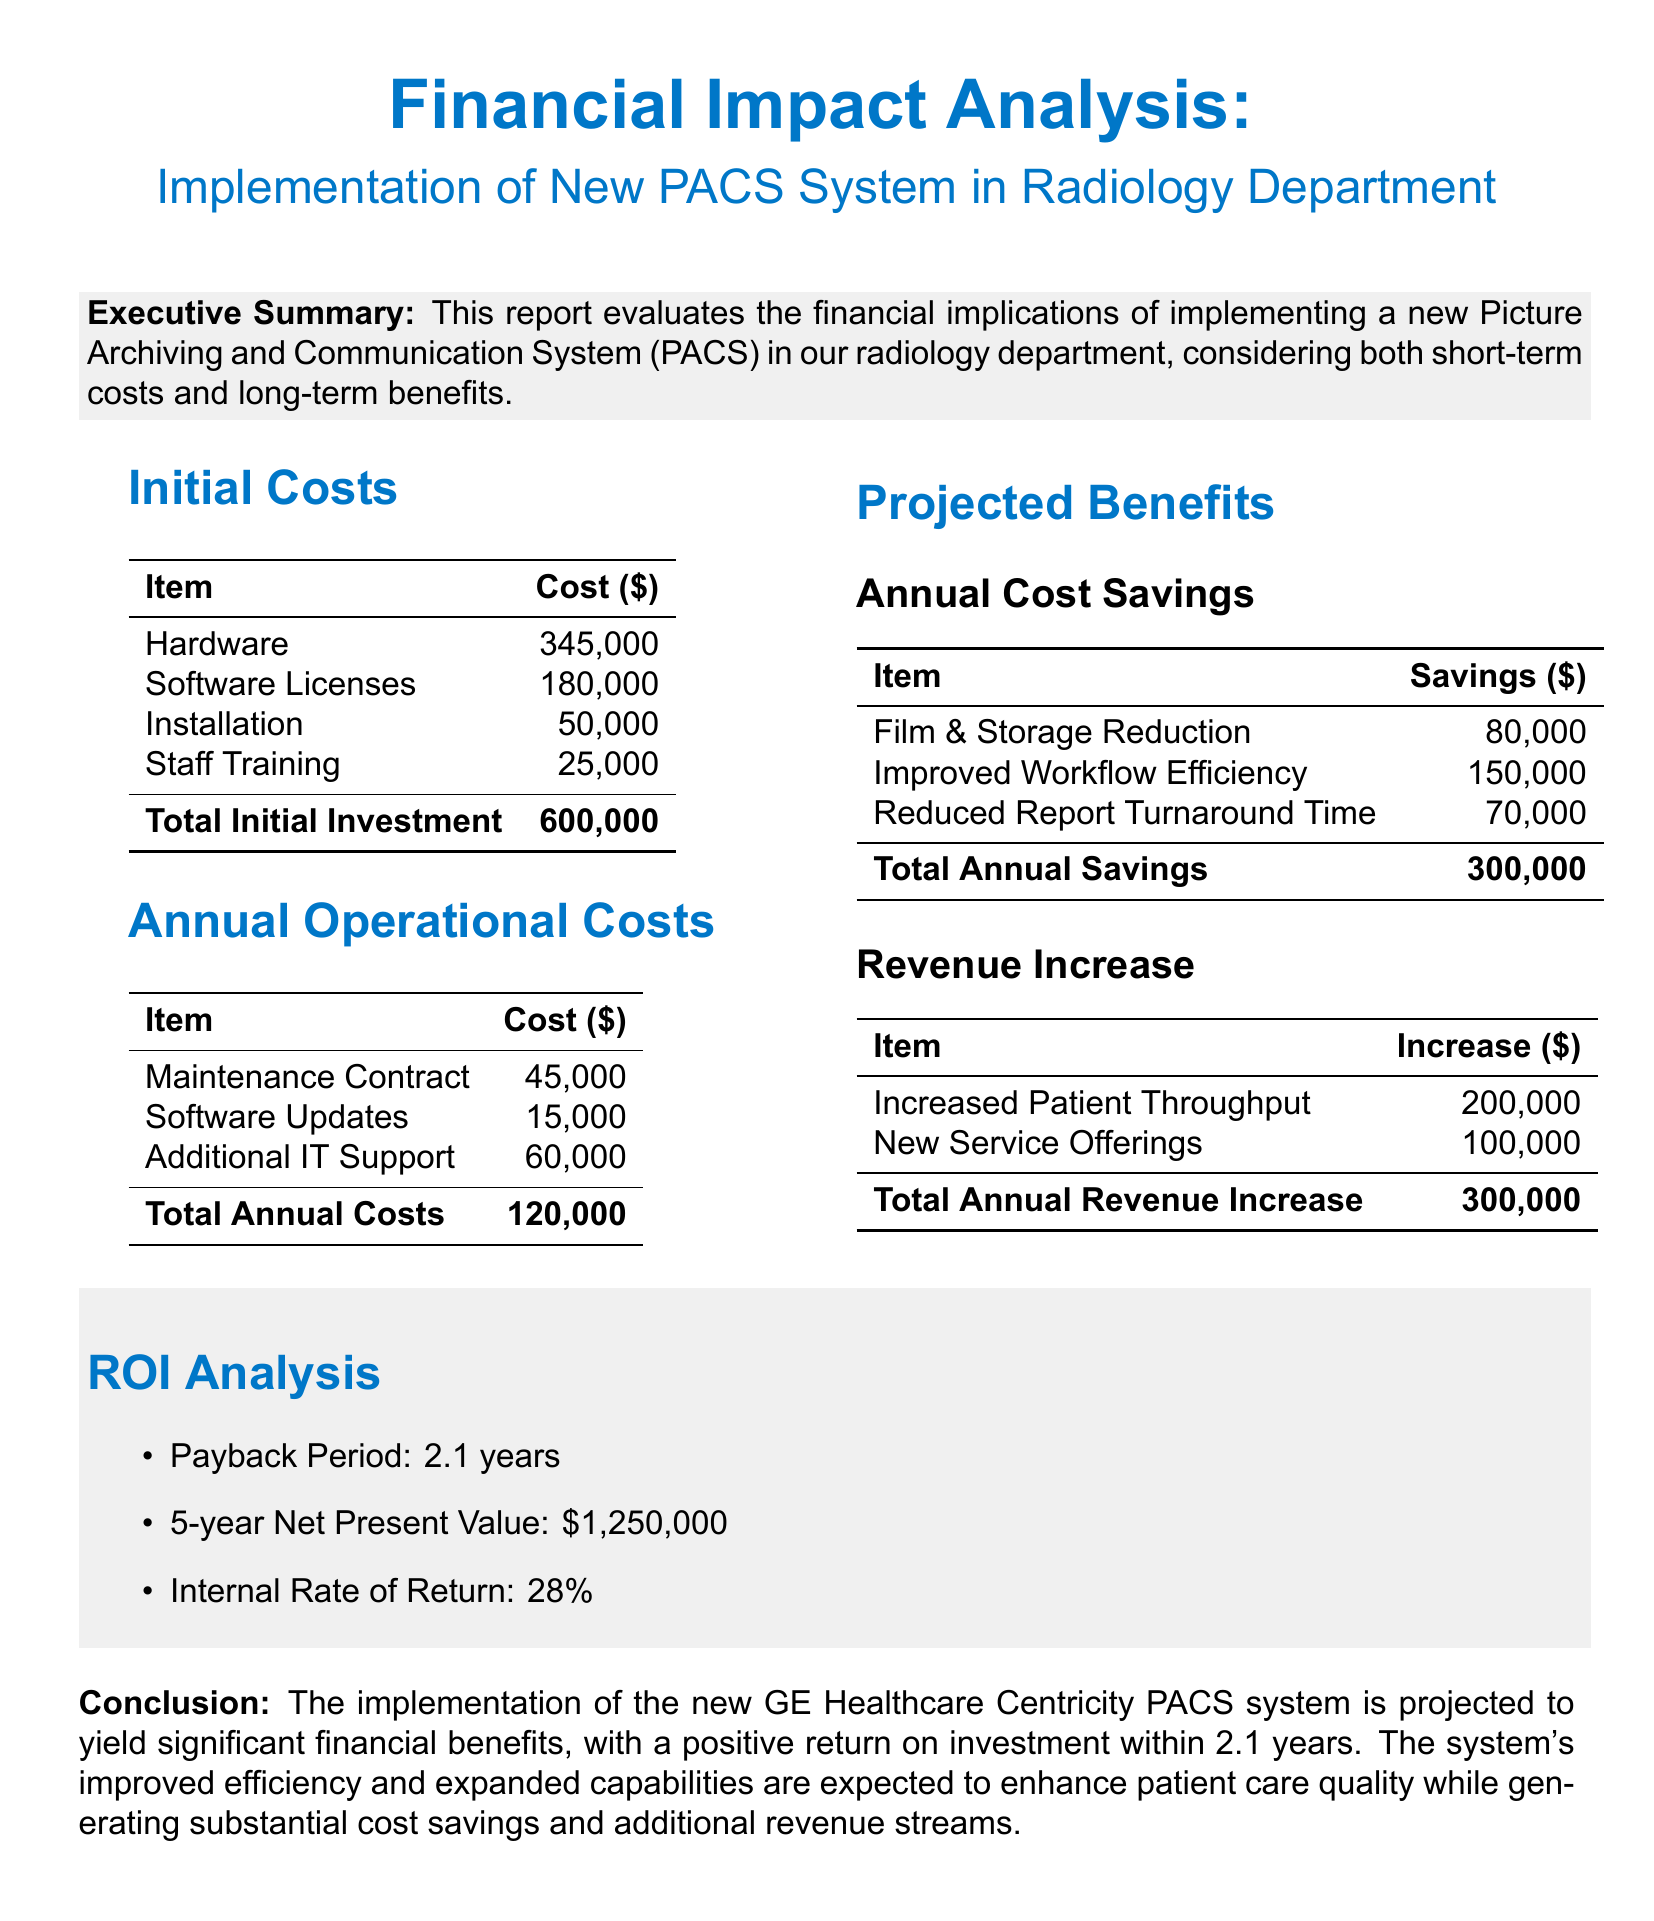What is the total initial investment? The total initial investment is provided in the initial costs section of the document.
Answer: 600,000 What is the payback period? The payback period is listed under the ROI analysis section of the report.
Answer: 2.1 years How much is spent on staff training? The cost for staff training is stated in the initial costs section of the report.
Answer: 25,000 What is the total annual revenue increase? The total annual revenue increase is the sum of increased patient throughput and new service offerings in the projected benefits section.
Answer: 300,000 What is the internal rate of return? The internal rate of return is specified in the ROI analysis section of the report.
Answer: 28% How much does the maintenance contract cost annually? The cost of the maintenance contract is detailed in the annual operational costs section.
Answer: 45,000 What are the total annual costs? Total annual costs are calculated by summing the annual operational costs in the report.
Answer: 120,000 Which PACS system is being implemented? The PACS system being implemented is mentioned in the conclusion section of the document.
Answer: GE Healthcare Centricity PACS What is the total annual savings? The total annual savings are highlighted in the projected benefits section, combining the savings from various categories.
Answer: 300,000 